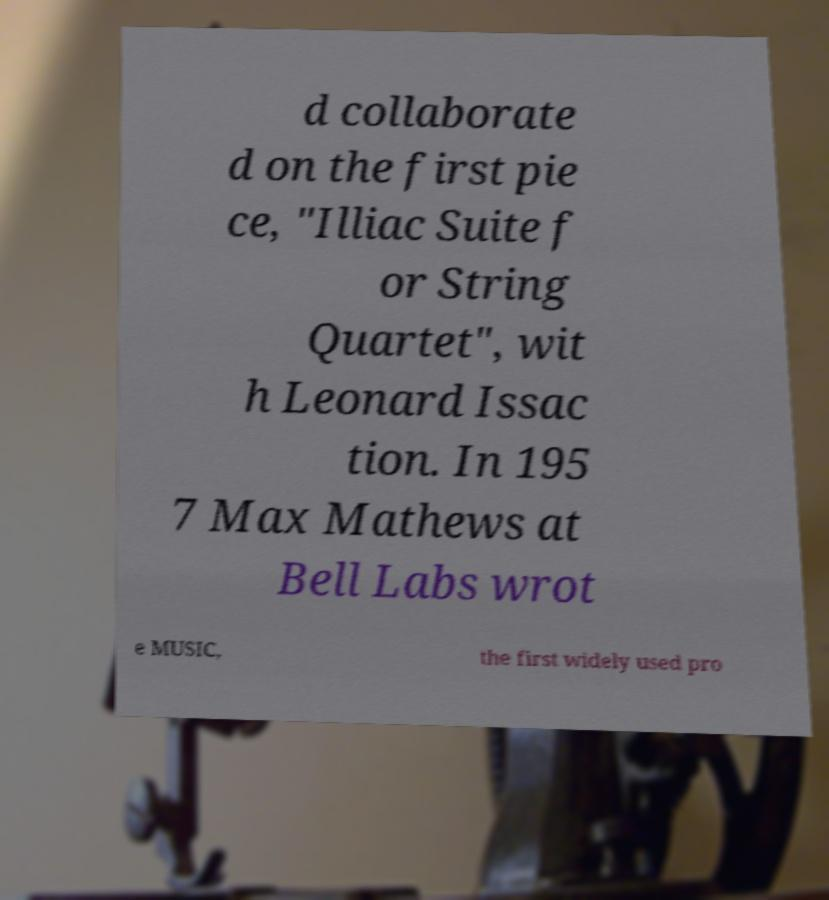For documentation purposes, I need the text within this image transcribed. Could you provide that? d collaborate d on the first pie ce, "Illiac Suite f or String Quartet", wit h Leonard Issac tion. In 195 7 Max Mathews at Bell Labs wrot e MUSIC, the first widely used pro 